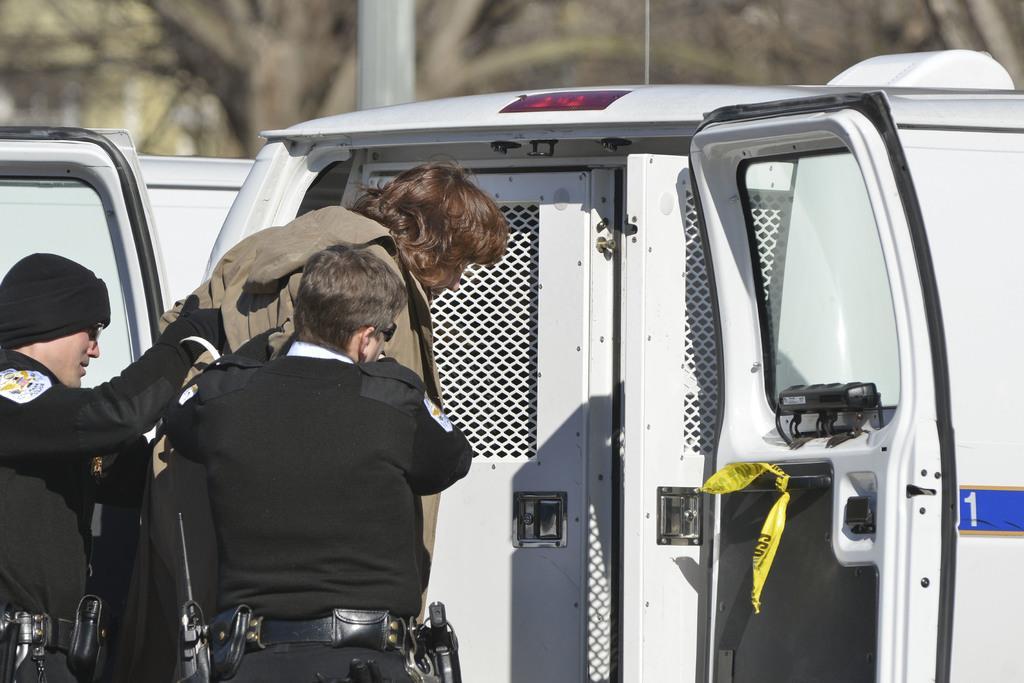How would you summarize this image in a sentence or two? In this picture, we see three people are standing. Out of them, two are in the uniform and the woman in the jacket is getting into the white vehicle. Beside that, we see a pole. There are trees in the background. This picture is blurred in the background. 